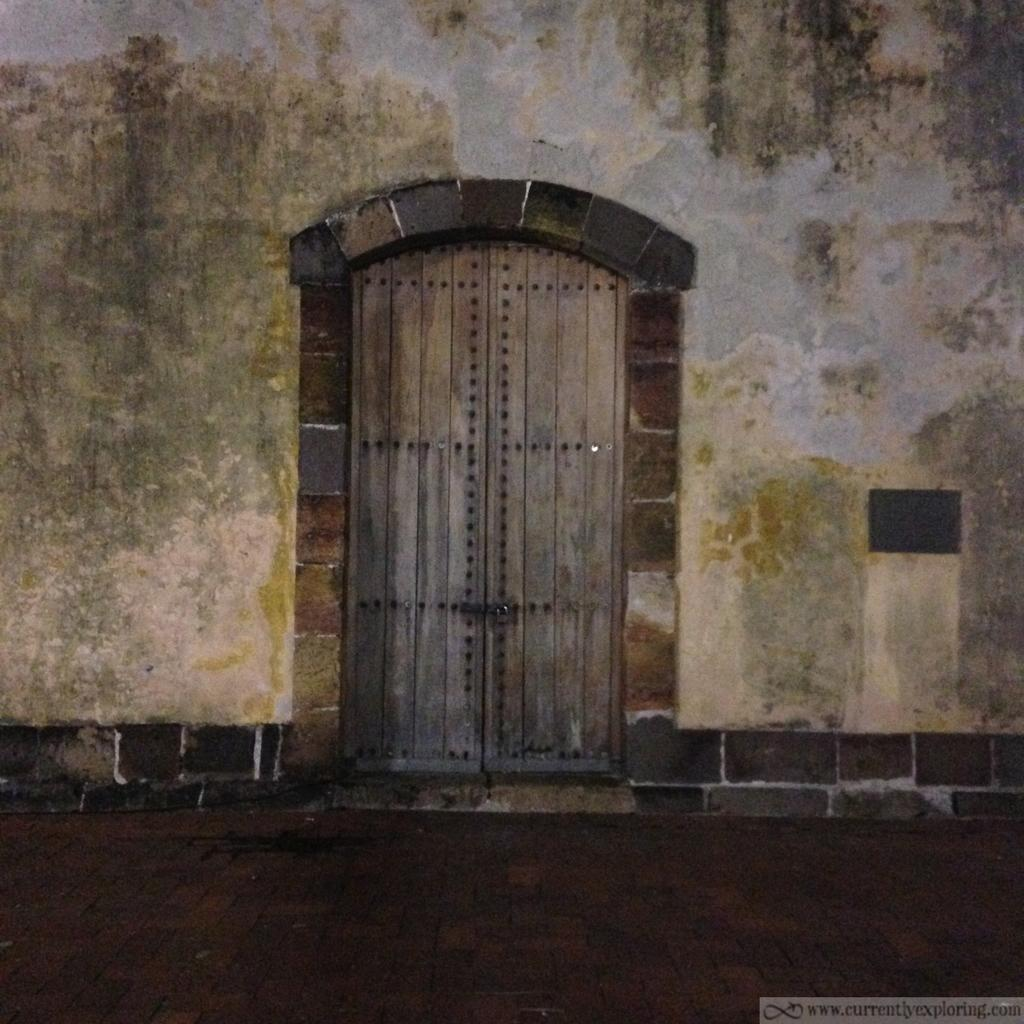What type of structure can be seen in the center of the image? There is a door and a wall in the center of the image. What is the primary function of the door? The door is likely used for entering or exiting a room or building. What is the purpose of the wall in the image? The wall serves as a barrier or divider between spaces. What can be found at the bottom side of the image? There is text at the bottom side of the image. How many cows are grazing near the door in the image? There are no cows present in the image; it only features a door and a wall. Is there a light bulb hanging from the ceiling in the image? There is no mention of a light bulb or any other lighting fixture in the image. 